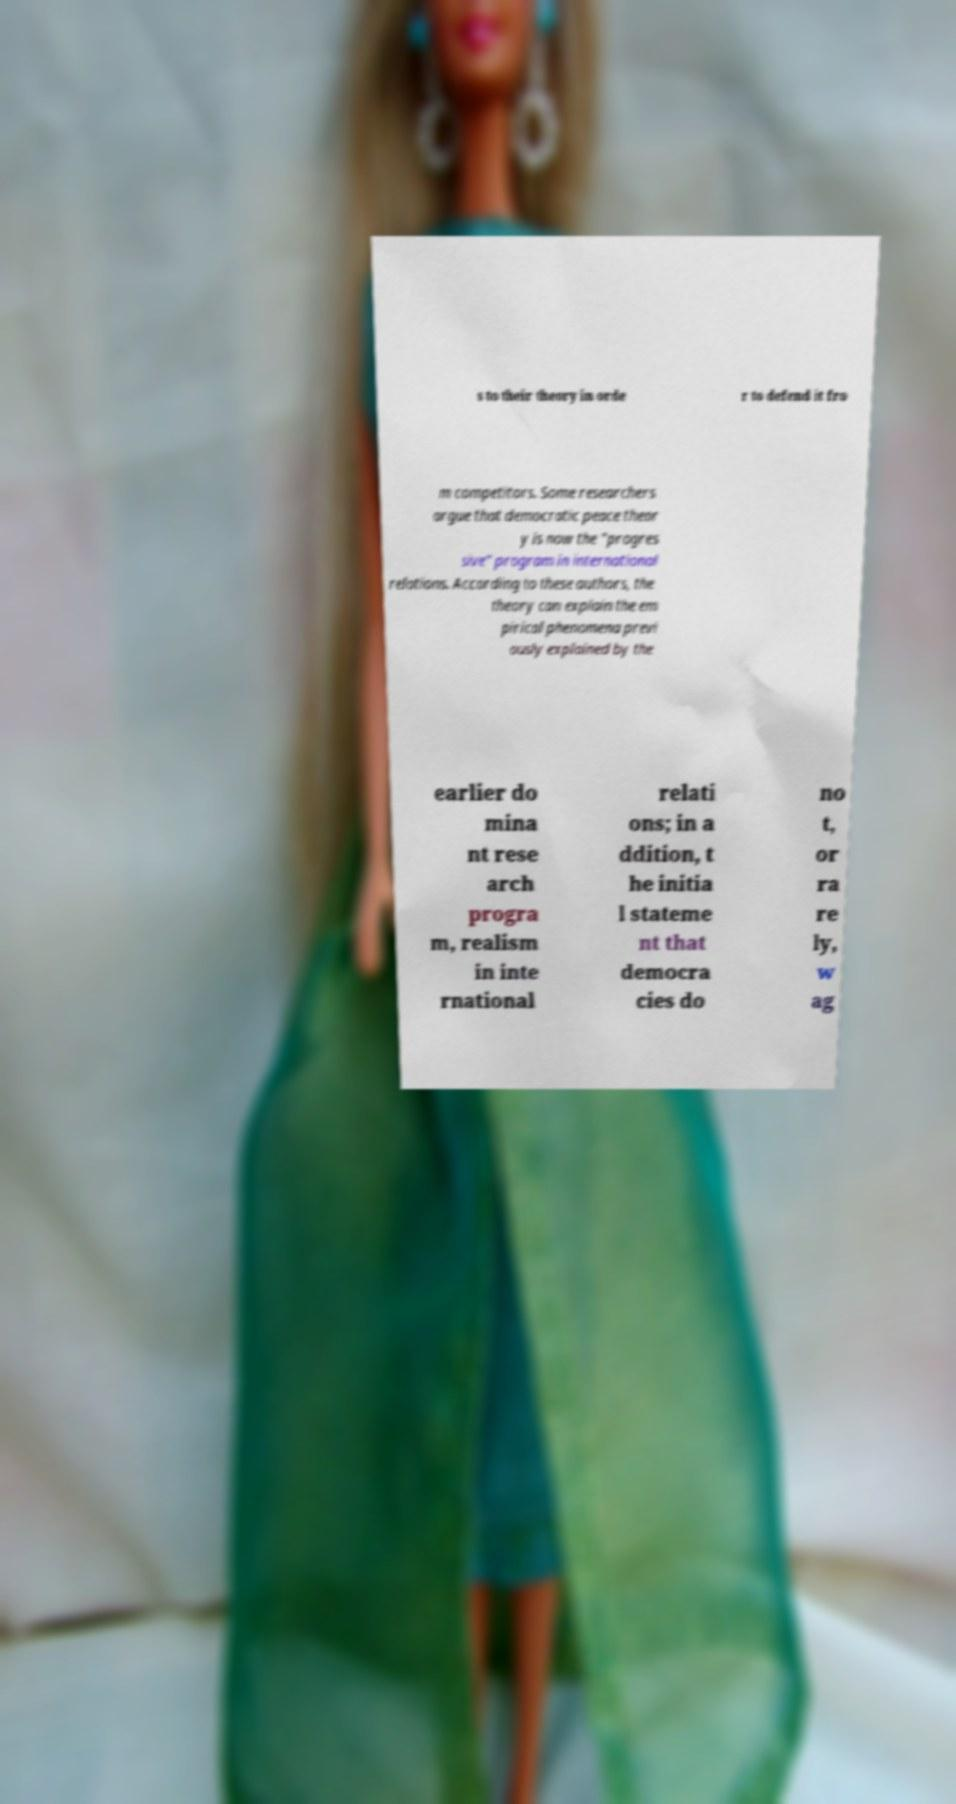Please identify and transcribe the text found in this image. s to their theory in orde r to defend it fro m competitors. Some researchers argue that democratic peace theor y is now the "progres sive" program in international relations. According to these authors, the theory can explain the em pirical phenomena previ ously explained by the earlier do mina nt rese arch progra m, realism in inte rnational relati ons; in a ddition, t he initia l stateme nt that democra cies do no t, or ra re ly, w ag 